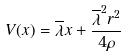<formula> <loc_0><loc_0><loc_500><loc_500>V ( x ) = \overline { \lambda } x + \frac { \overline { \lambda } ^ { 2 } r ^ { 2 } } { 4 \rho }</formula> 